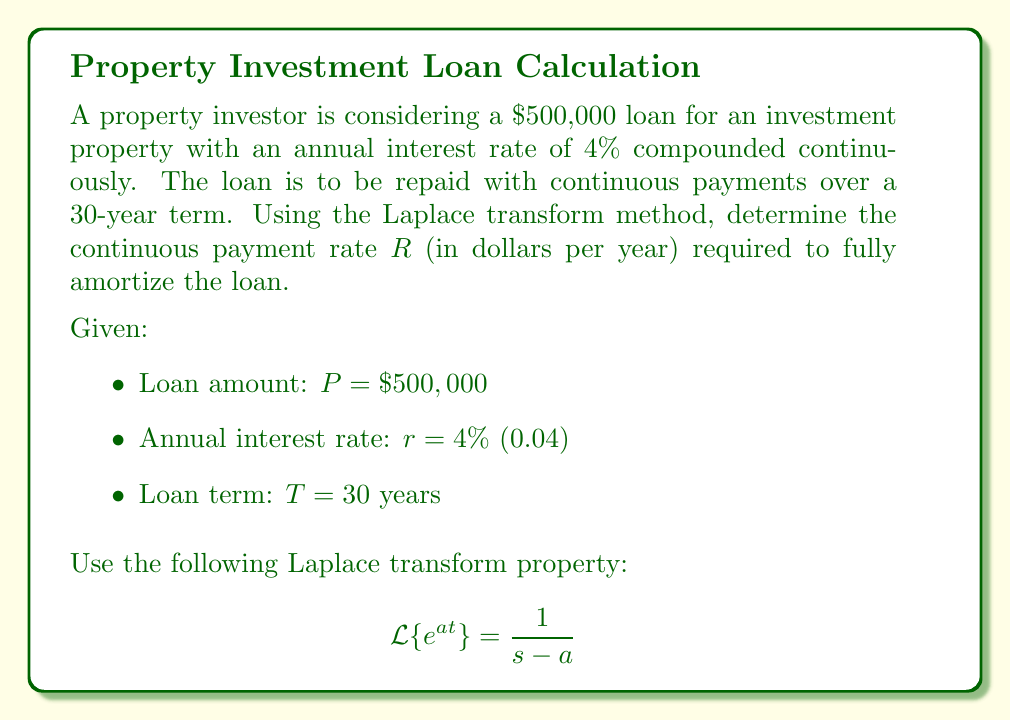Could you help me with this problem? Let's solve this step-by-step using the Laplace transform method:

1) The differential equation for the loan balance $B(t)$ is:
   $$\frac{dB}{dt} = rB - R$$
   where $r$ is the interest rate and $R$ is the continuous payment rate.

2) Taking the Laplace transform of both sides:
   $$s\mathcal{L}\{B\} - B(0) = r\mathcal{L}\{B\} - \frac{R}{s}$$

3) Let $\mathcal{L}\{B\} = X(s)$. We know $B(0) = P = 500,000$. Substituting:
   $$sX(s) - 500,000 = rX(s) - \frac{R}{s}$$

4) Rearranging terms:
   $$(s-r)X(s) = 500,000 + \frac{R}{s}$$

5) Solving for $X(s)$:
   $$X(s) = \frac{500,000}{s-r} + \frac{R}{s(s-r)}$$

6) The loan should be fully paid off at time $T$, so $B(T) = 0$. In the s-domain, this translates to:
   $$\lim_{t \to T} B(t) = \lim_{s \to 0} sX(s) = 0$$

7) Applying this condition:
   $$\lim_{s \to 0} s\left(\frac{500,000}{s-r} + \frac{R}{s(s-r)}\right) = 0$$

8) Simplifying:
   $$500,000 + \frac{R}{r} = 500,000e^{rT}$$

9) Solving for $R$:
   $$R = 500,000r\frac{e^{rT} - 1}{e^{rT}}$$

10) Substituting the values $r = 0.04$ and $T = 30$:
    $$R = 500,000 \times 0.04 \times \frac{e^{0.04 \times 30} - 1}{e^{0.04 \times 30}} = 28,721.84$$

Therefore, the continuous payment rate $R$ required to fully amortize the loan is $28,721.84 per year.
Answer: $28,721.84 per year 